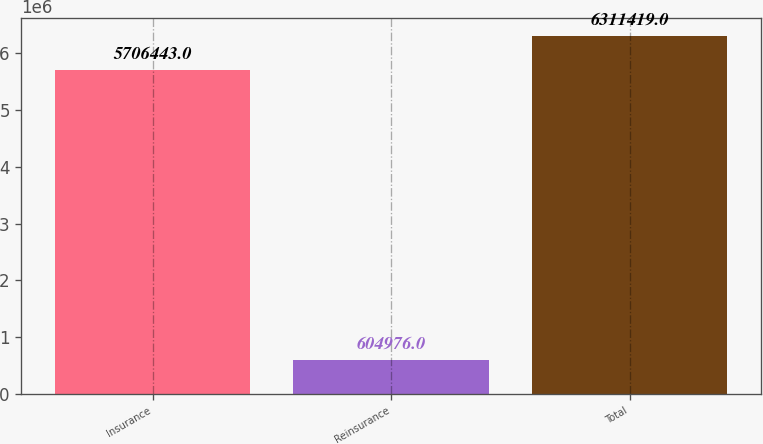<chart> <loc_0><loc_0><loc_500><loc_500><bar_chart><fcel>Insurance<fcel>Reinsurance<fcel>Total<nl><fcel>5.70644e+06<fcel>604976<fcel>6.31142e+06<nl></chart> 